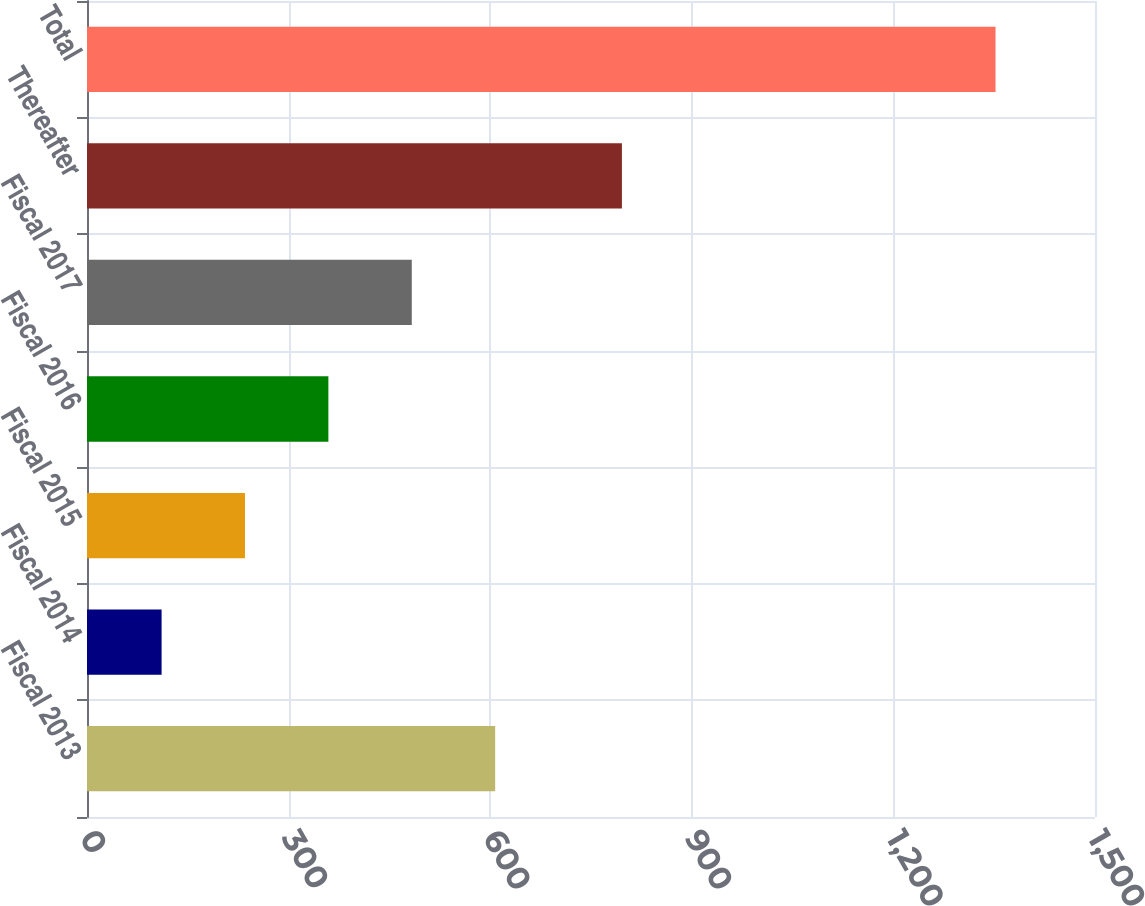Convert chart to OTSL. <chart><loc_0><loc_0><loc_500><loc_500><bar_chart><fcel>Fiscal 2013<fcel>Fiscal 2014<fcel>Fiscal 2015<fcel>Fiscal 2016<fcel>Fiscal 2017<fcel>Thereafter<fcel>Total<nl><fcel>607.4<fcel>111<fcel>235.1<fcel>359.2<fcel>483.3<fcel>796<fcel>1352<nl></chart> 